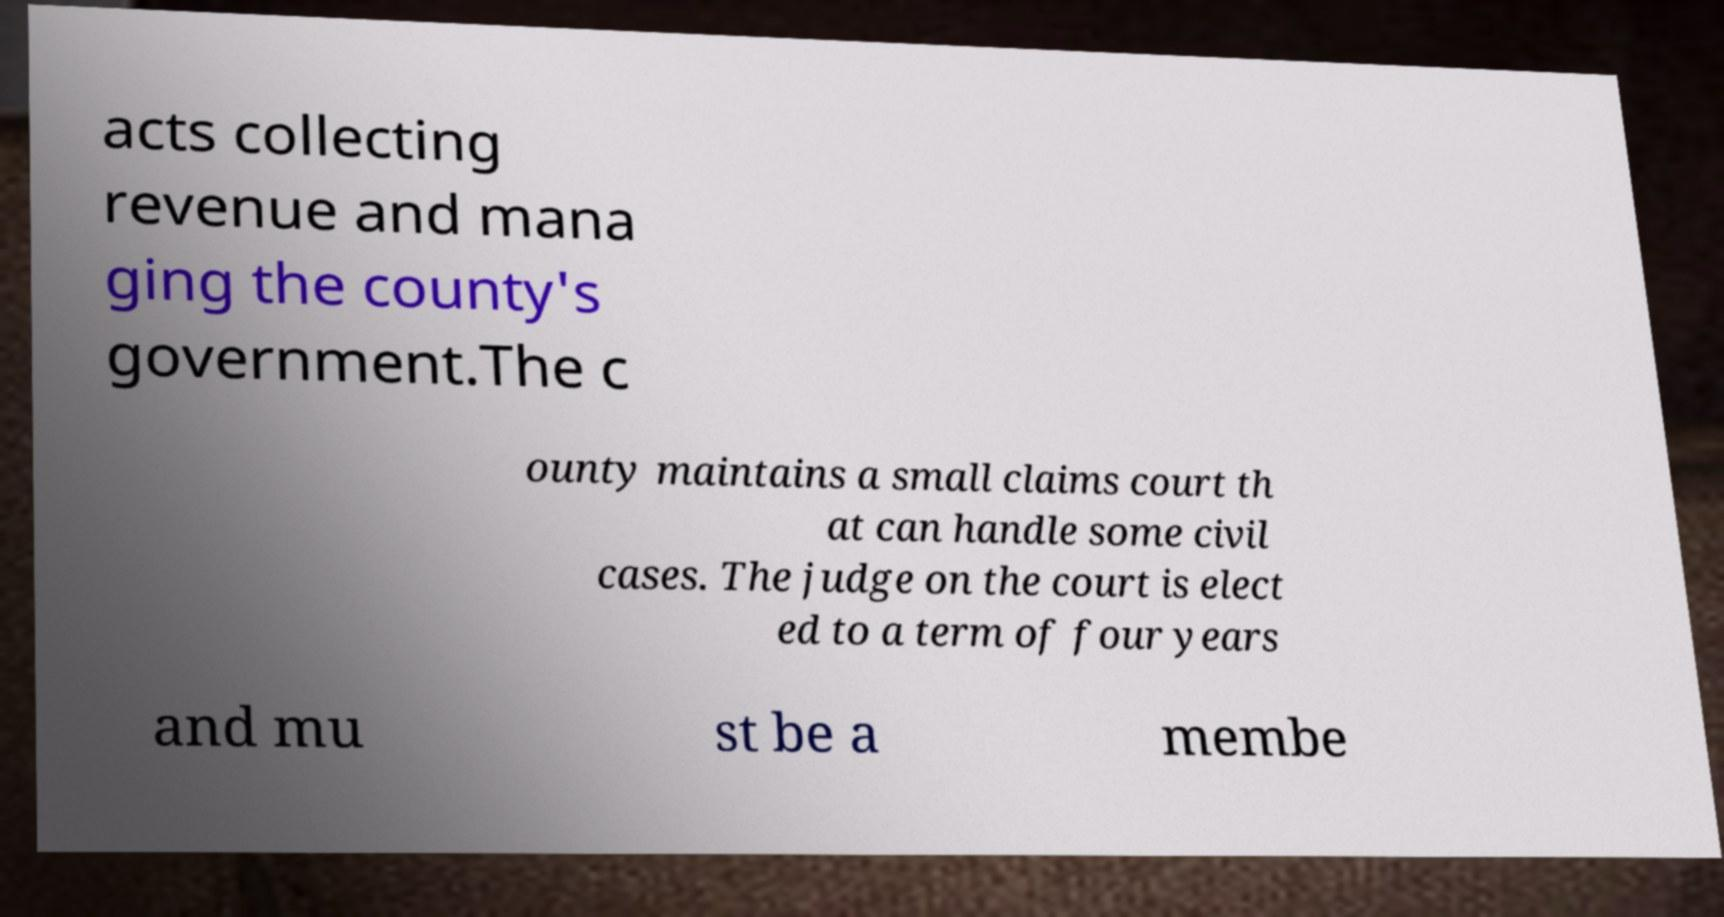Could you extract and type out the text from this image? acts collecting revenue and mana ging the county's government.The c ounty maintains a small claims court th at can handle some civil cases. The judge on the court is elect ed to a term of four years and mu st be a membe 